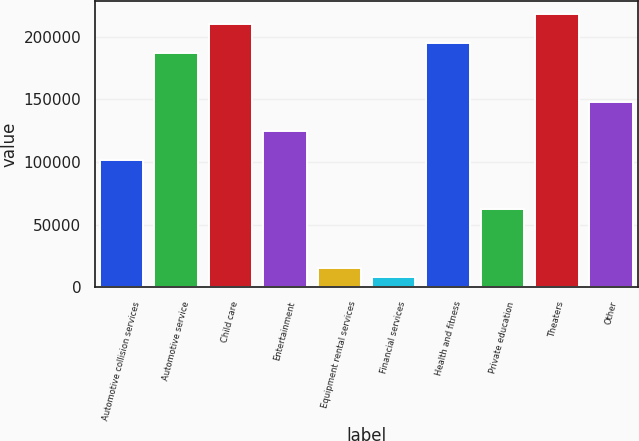Convert chart. <chart><loc_0><loc_0><loc_500><loc_500><bar_chart><fcel>Automotive collision services<fcel>Automotive service<fcel>Child care<fcel>Entertainment<fcel>Equipment rental services<fcel>Financial services<fcel>Health and fitness<fcel>Private education<fcel>Theaters<fcel>Other<nl><fcel>101320<fcel>187005<fcel>210374<fcel>124689<fcel>15636<fcel>7846.5<fcel>194794<fcel>62373<fcel>218163<fcel>148058<nl></chart> 